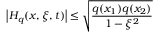<formula> <loc_0><loc_0><loc_500><loc_500>\left | H _ { q } ( x , \xi , t ) \right | \leq \sqrt { \frac { q ( x _ { 1 } ) q ( x _ { 2 } ) } { 1 - \xi ^ { 2 } } }</formula> 